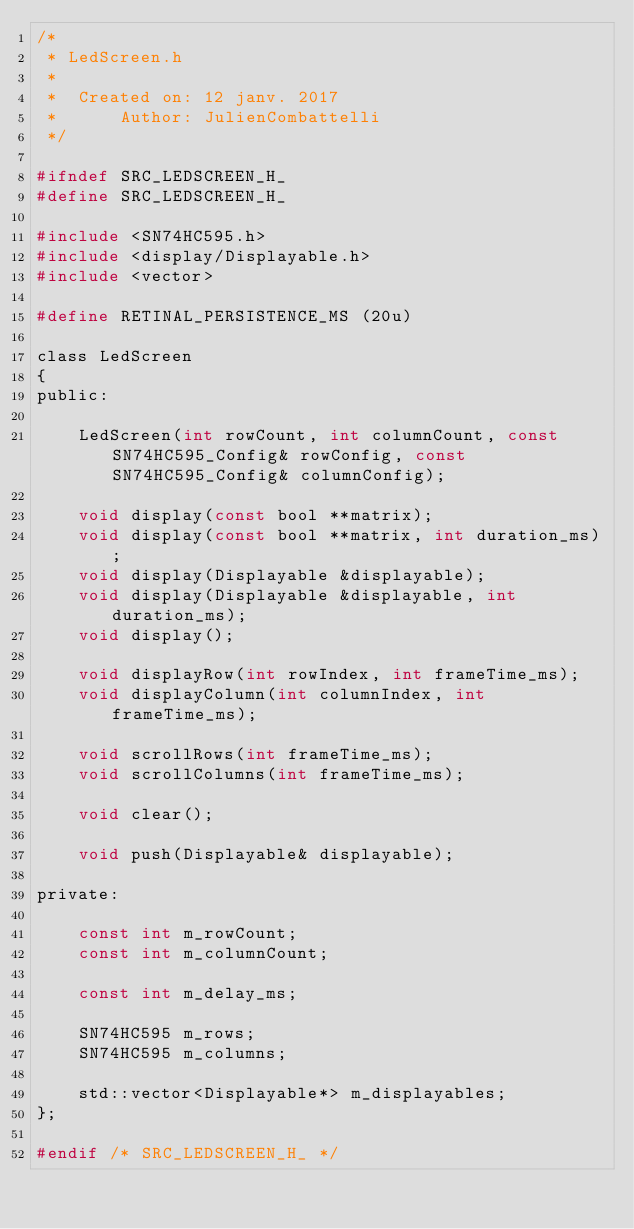Convert code to text. <code><loc_0><loc_0><loc_500><loc_500><_C_>/*
 * LedScreen.h
 *
 *  Created on: 12 janv. 2017
 *      Author: JulienCombattelli
 */

#ifndef SRC_LEDSCREEN_H_
#define SRC_LEDSCREEN_H_

#include <SN74HC595.h>
#include <display/Displayable.h>
#include <vector>

#define RETINAL_PERSISTENCE_MS (20u)

class LedScreen
{
public:

	LedScreen(int rowCount, int columnCount, const SN74HC595_Config& rowConfig, const SN74HC595_Config& columnConfig);

	void display(const bool **matrix);
	void display(const bool **matrix, int duration_ms);
	void display(Displayable &displayable);
	void display(Displayable &displayable, int duration_ms);
	void display();

	void displayRow(int rowIndex, int frameTime_ms);
	void displayColumn(int columnIndex, int frameTime_ms);

	void scrollRows(int frameTime_ms);
	void scrollColumns(int frameTime_ms);

	void clear();

	void push(Displayable& displayable);

private:

	const int m_rowCount;
	const int m_columnCount;

	const int m_delay_ms;

	SN74HC595 m_rows;
	SN74HC595 m_columns;

	std::vector<Displayable*> m_displayables;
};

#endif /* SRC_LEDSCREEN_H_ */
</code> 